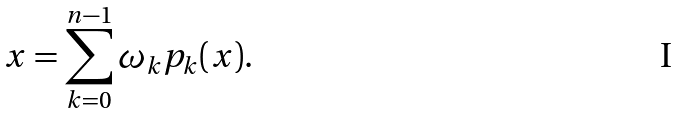<formula> <loc_0><loc_0><loc_500><loc_500>x = \sum _ { k = 0 } ^ { n - 1 } \omega _ { k } p _ { k } ( x ) .</formula> 